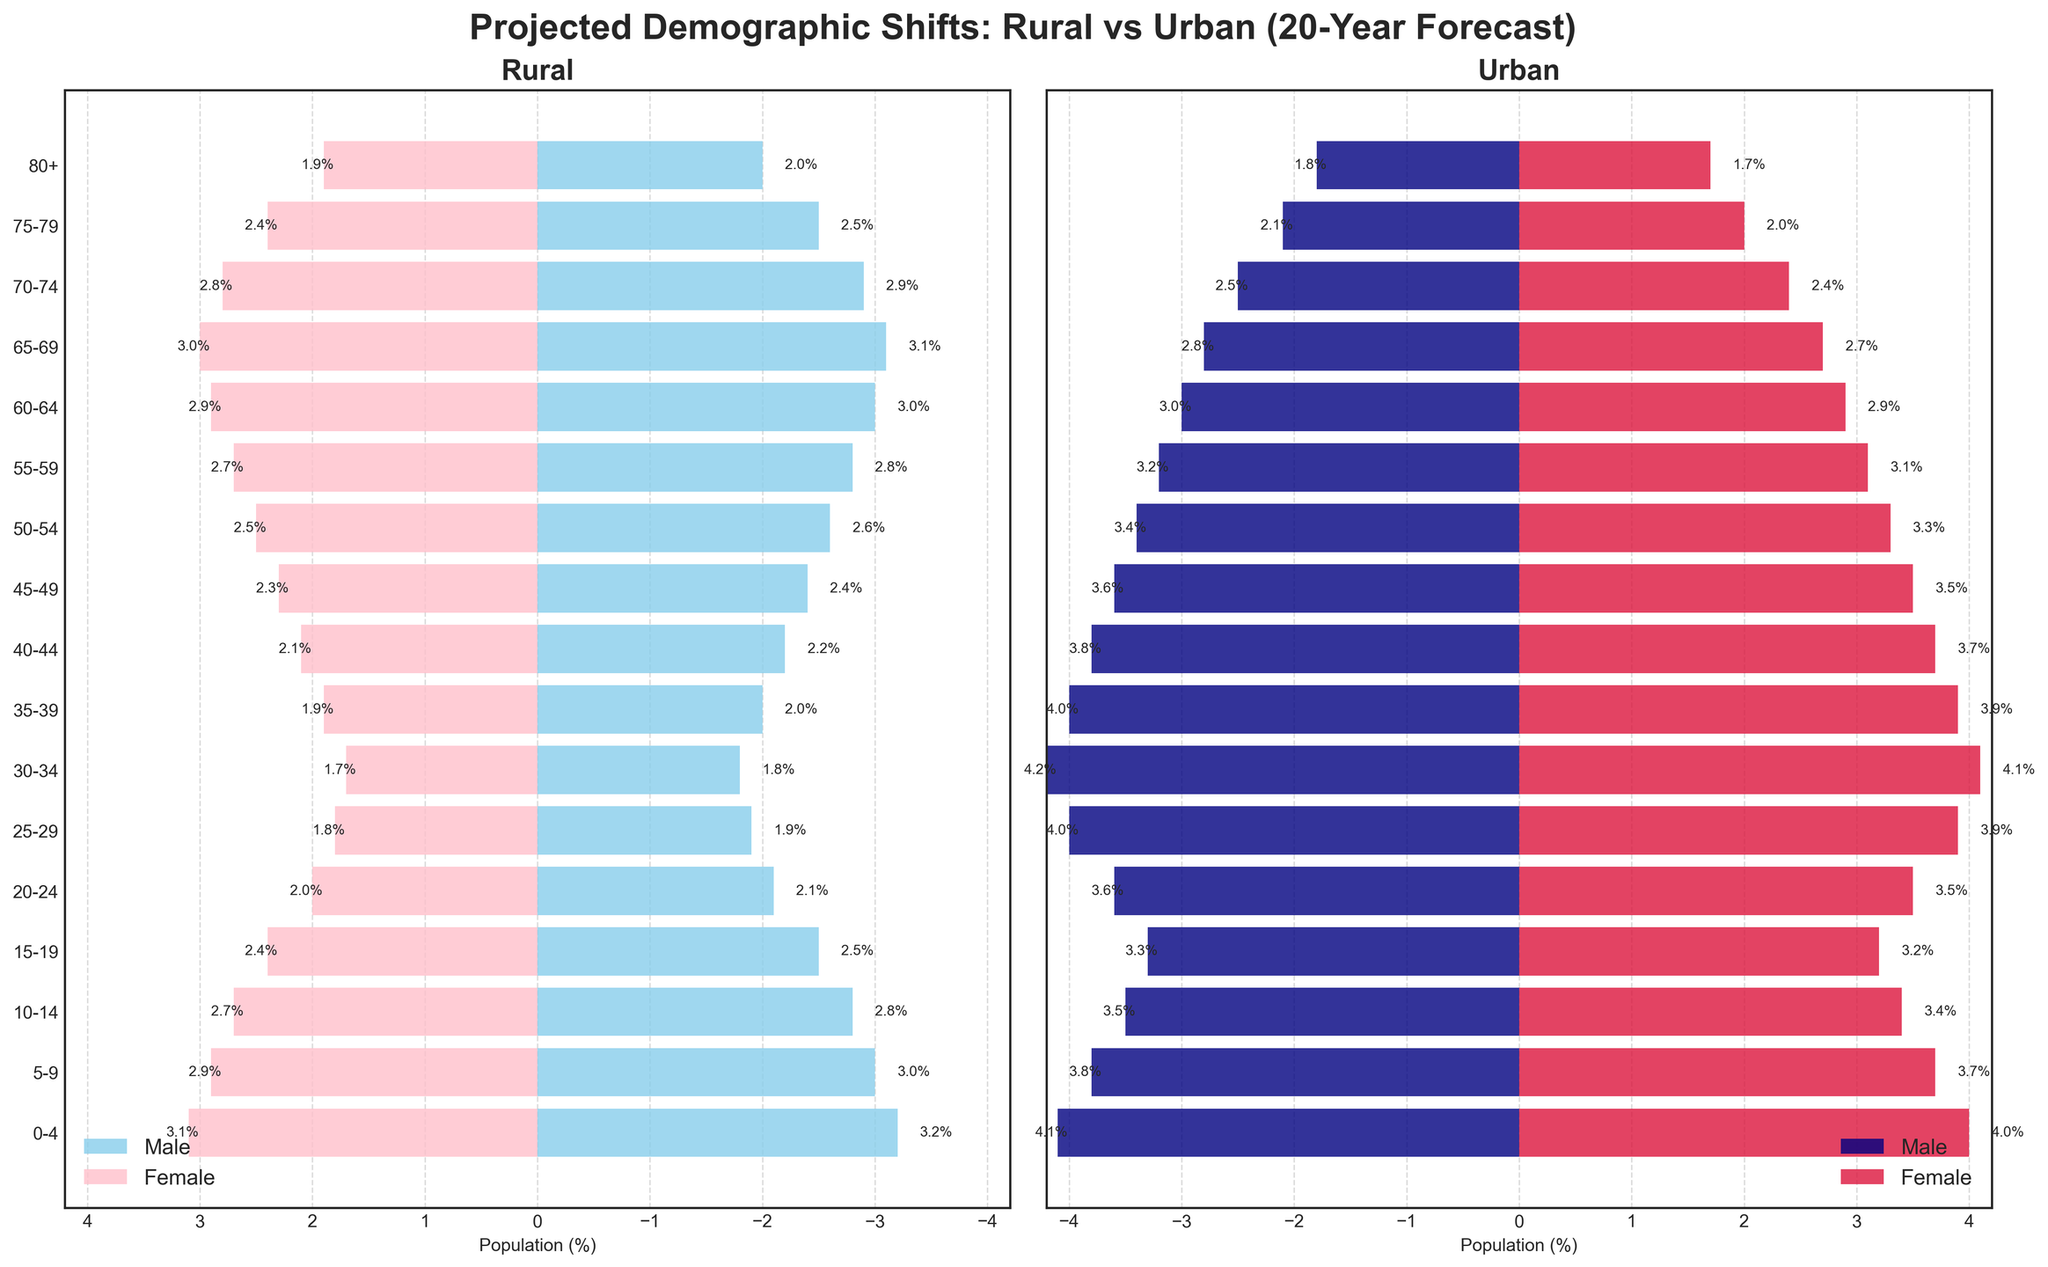What is the overall title of the figure? The overall title is located at the top center of the figure. It states, "Projected Demographic Shifts: Rural vs Urban (20-Year Forecast)."
Answer: Projected Demographic Shifts: Rural vs Urban (20-Year Forecast) How is the population distribution at age group 25-29 different between rural and urban areas? For the age group 25-29, the rural male population percentage is -1.9% and the rural female population percentage is 1.8%, whereas the urban male population percentage is -4.0% and the urban female population percentage is 3.9%.
Answer: Urban has higher percentages What age group has the highest urban female population percentage? By examining the bars in the urban section, the age group 30-34 has the highest urban female population percentage at 4.1%.
Answer: 30-34 Which gender has a larger population percentage in rural areas for the age group 65-69? The rural male population percentage for the age group 65-69 is -3.1%, and the rural female population percentage is 3.0%. Rural males have a slightly larger percentage.
Answer: Rural males Comparing urban males and females, do younger or older age groups have a more balanced distribution? For urban males and females, the younger age groups (0-4, 5-9) show a larger difference, whereas the older age groups (80+) have both urban males and females at around -1.8% and 1.7%. Therefore, older age groups have a more balanced distribution.
Answer: Older age groups What is the total percentage of the urban population in the age group 70-74? Adding the absolute values of the urban male population (-2.5%) and urban female population (2.4%) for the age group 70-74, the total percentage is 2.5 + 2.4 = 4.9%.
Answer: 4.9% For the age group 40-44, is the urban male or female population larger, and by how much? The urban male population percentage for the age group 40-44 is -3.8%, and the urban female population percentage is 3.7%. The urban male population is slightly larger by 0.1%.
Answer: Urban male by 0.1% What is the trend in population percentages for rural males and females from the youngest to the oldest age group? Observing the rural male and female bars from the youngest (0-4) to oldest (80+), both genders show a decreasing trend in population percentage.
Answer: Decreasing trend What age group has the smallest population percentage difference between rural and urban females? The smallest difference in population percentage between rural and urban females is for the age group 60-64, with both having a percentage of 2.9%.
Answer: 60-64 